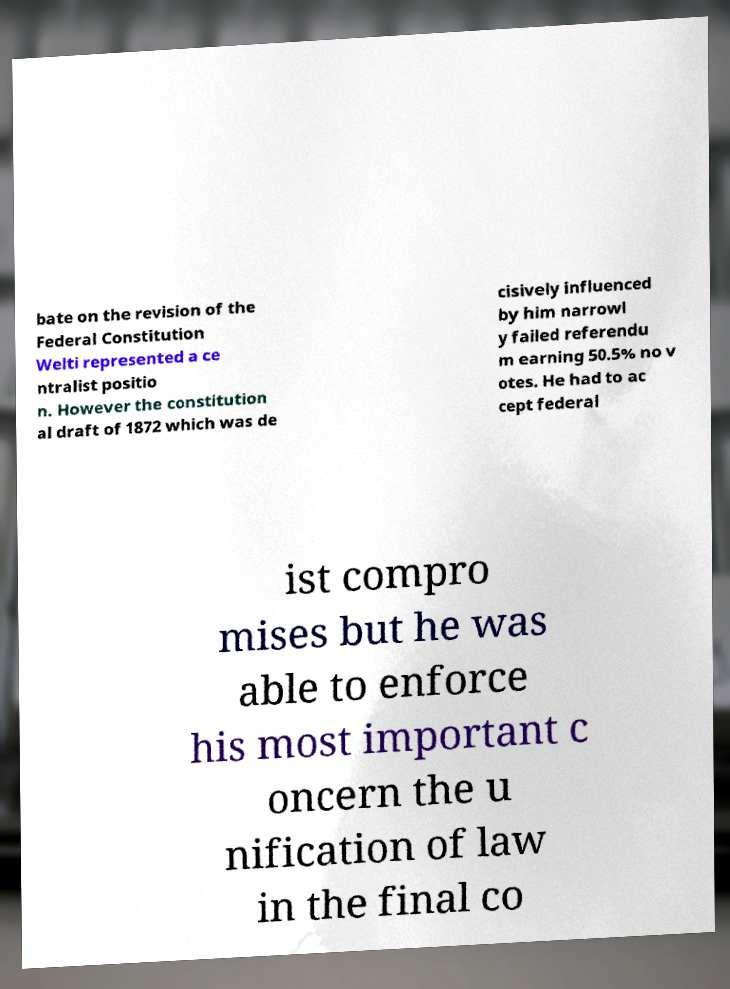Can you read and provide the text displayed in the image?This photo seems to have some interesting text. Can you extract and type it out for me? bate on the revision of the Federal Constitution Welti represented a ce ntralist positio n. However the constitution al draft of 1872 which was de cisively influenced by him narrowl y failed referendu m earning 50.5% no v otes. He had to ac cept federal ist compro mises but he was able to enforce his most important c oncern the u nification of law in the final co 